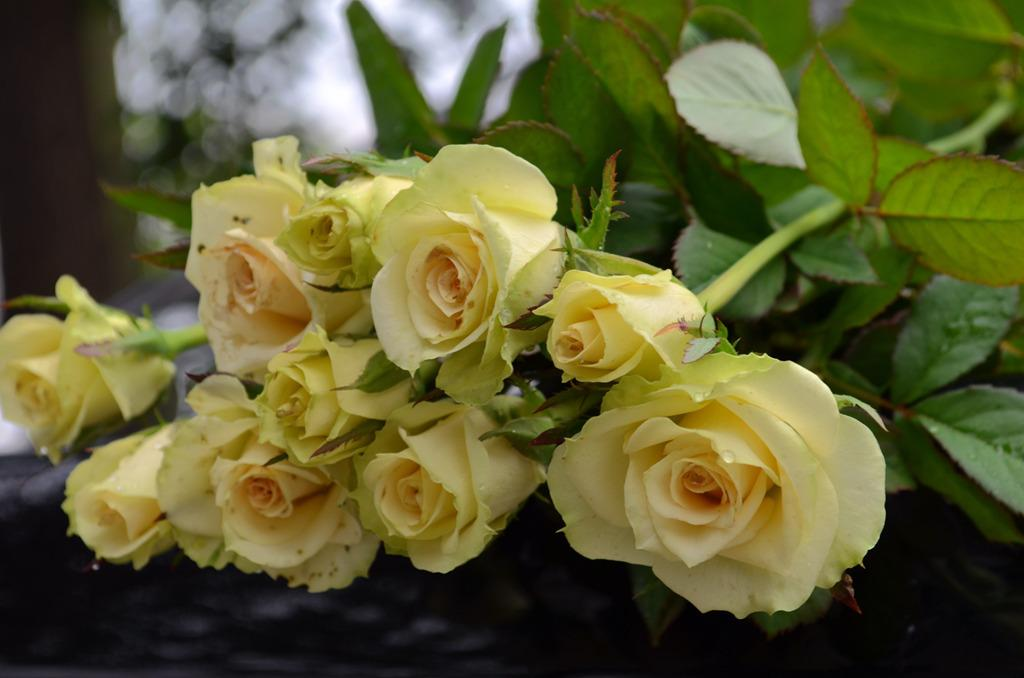What can be inferred about the location of the image? The image was likely taken outside, as there are no clear indications of an indoor setting. What types of plants are visible in the foreground of the image? There are roses and green leaves in the foreground of the image. How would you describe the background of the image? The background of the image is blurry. What type of metal is used to make the cheese in the image? There is no cheese present in the image, and therefore no metal can be associated with it. 